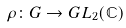<formula> <loc_0><loc_0><loc_500><loc_500>\rho \colon G \to { G L } _ { 2 } ( \mathbb { C } )</formula> 